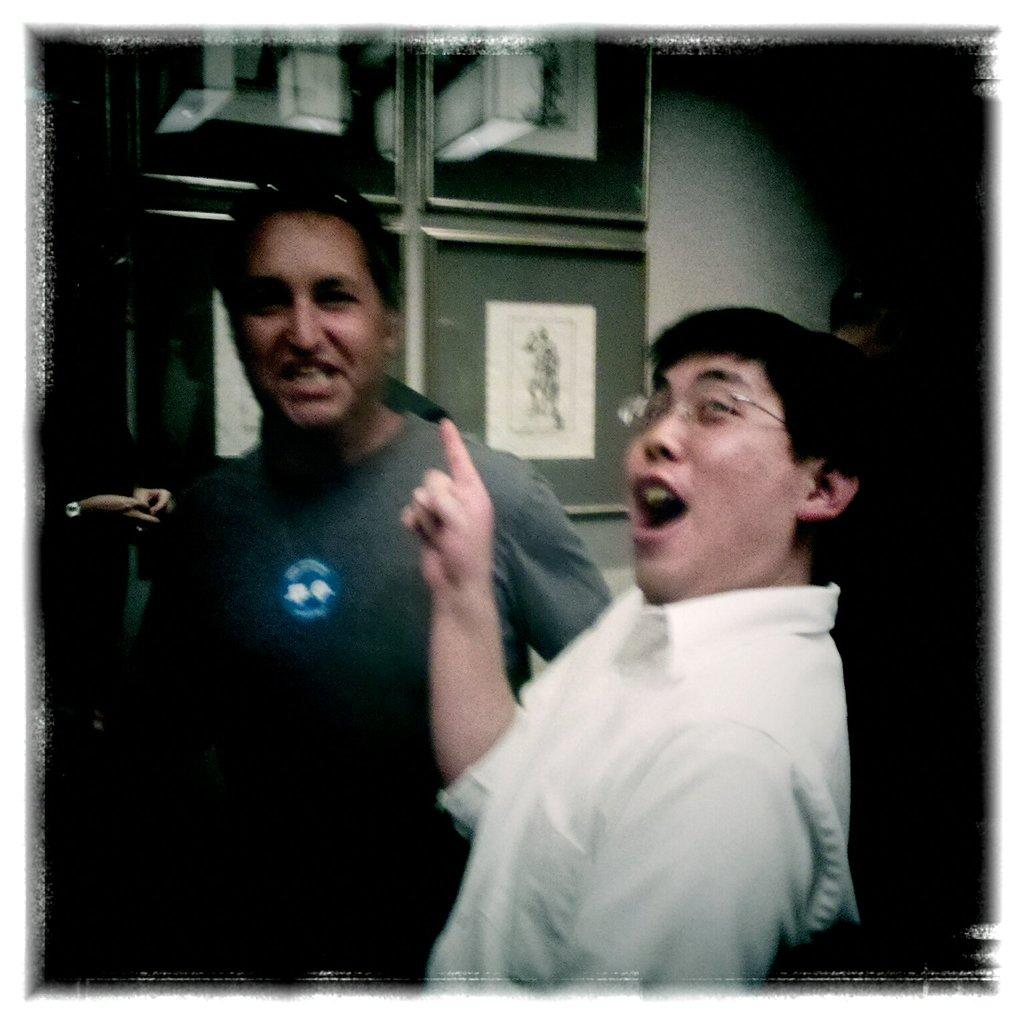How many people are in the image? There are people in the image, but the exact number is not specified. Can you describe any specific features of one of the people? One person is wearing glasses. What can be seen on the wall in the background? There are boards on the wall in the background. What else is visible in the background? There are other objects visible in the background, but their specific nature is not mentioned. What type of skin treatment is being applied to the person in the image? There is no indication in the image that any skin treatment is being applied to the person. How does the image show the people increasing their productivity? The image does not show any actions or activities that would suggest an increase in productivity. 